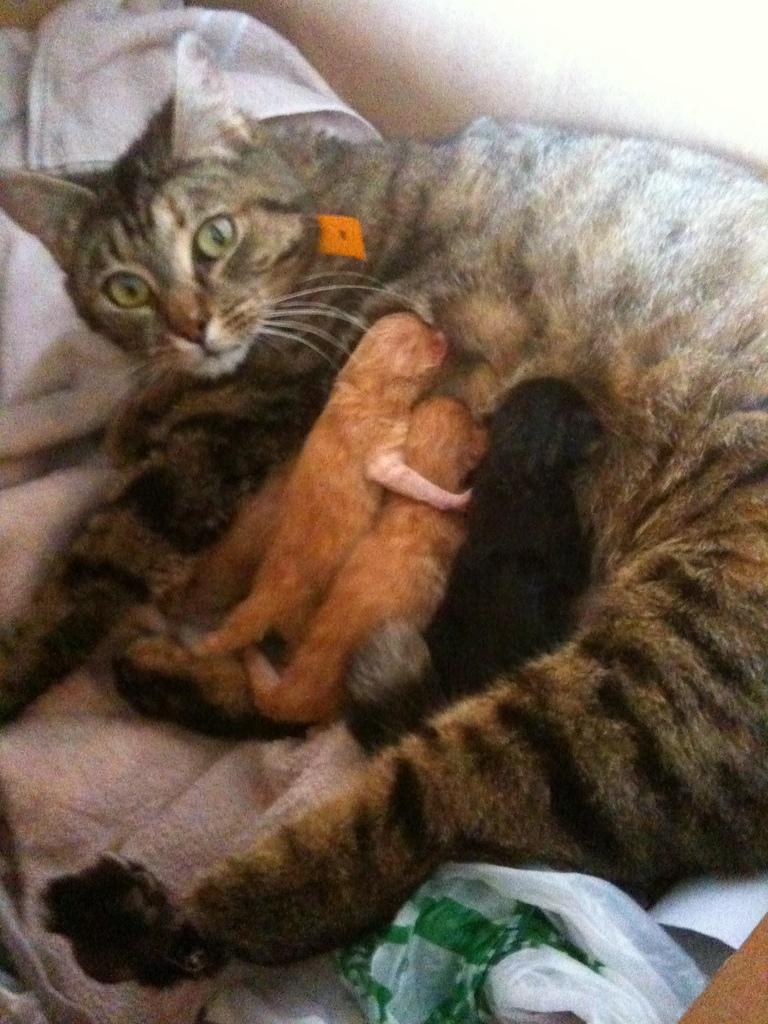What animals are present in the image? There are cats lying on a towel in the image. Can you describe the background color of the image? The background of the image is in blue. What type of shoes can be seen in the image? There are no shoes present in the image. Is there a skate visible in the image? There is no skate present in the image. What type of cream is being used by the cats in the image? There is no cream present in the image, and the cats are not using any cream. 